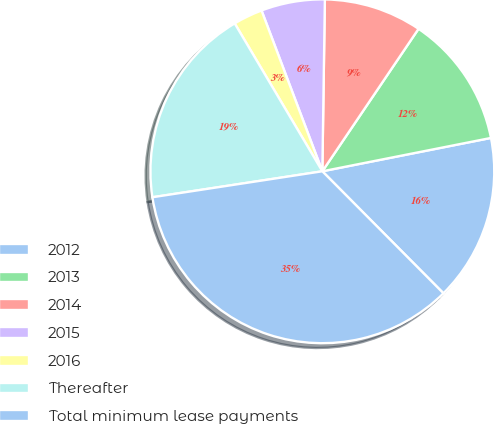Convert chart to OTSL. <chart><loc_0><loc_0><loc_500><loc_500><pie_chart><fcel>2012<fcel>2013<fcel>2014<fcel>2015<fcel>2016<fcel>Thereafter<fcel>Total minimum lease payments<nl><fcel>15.67%<fcel>12.44%<fcel>9.22%<fcel>5.99%<fcel>2.76%<fcel>18.9%<fcel>35.03%<nl></chart> 